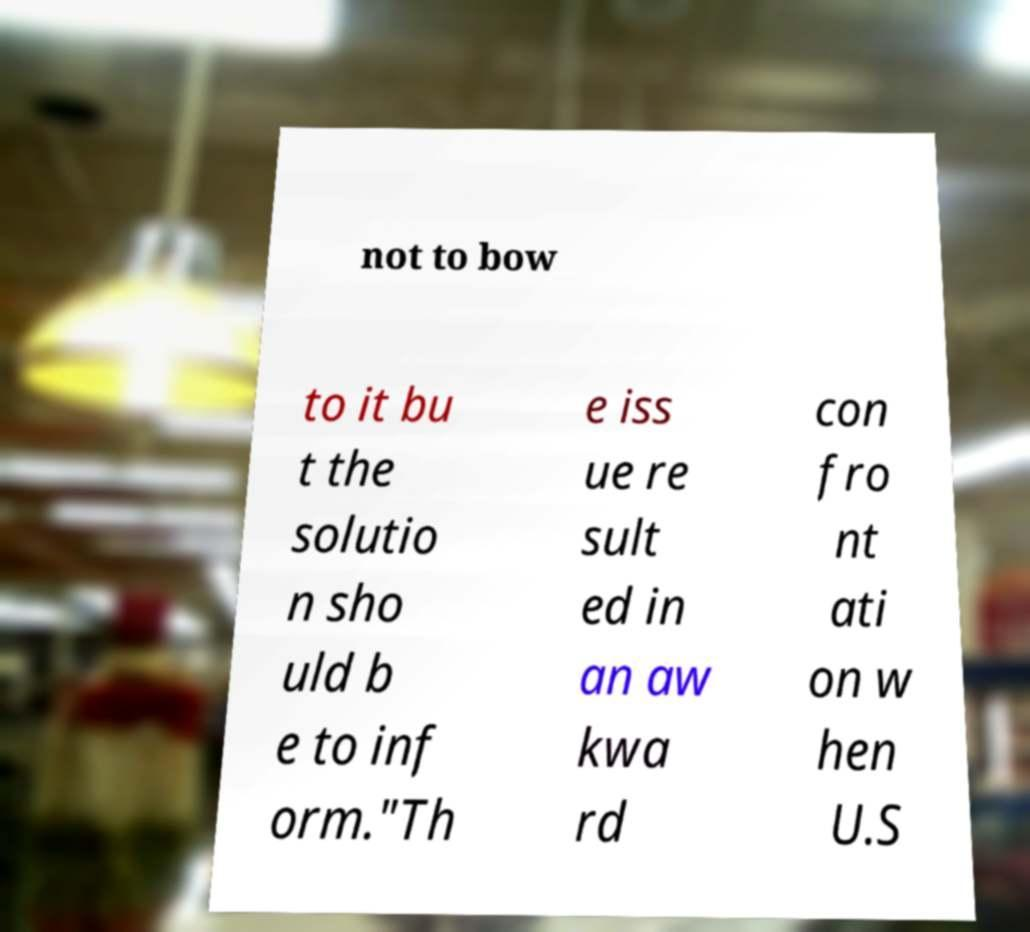There's text embedded in this image that I need extracted. Can you transcribe it verbatim? not to bow to it bu t the solutio n sho uld b e to inf orm."Th e iss ue re sult ed in an aw kwa rd con fro nt ati on w hen U.S 